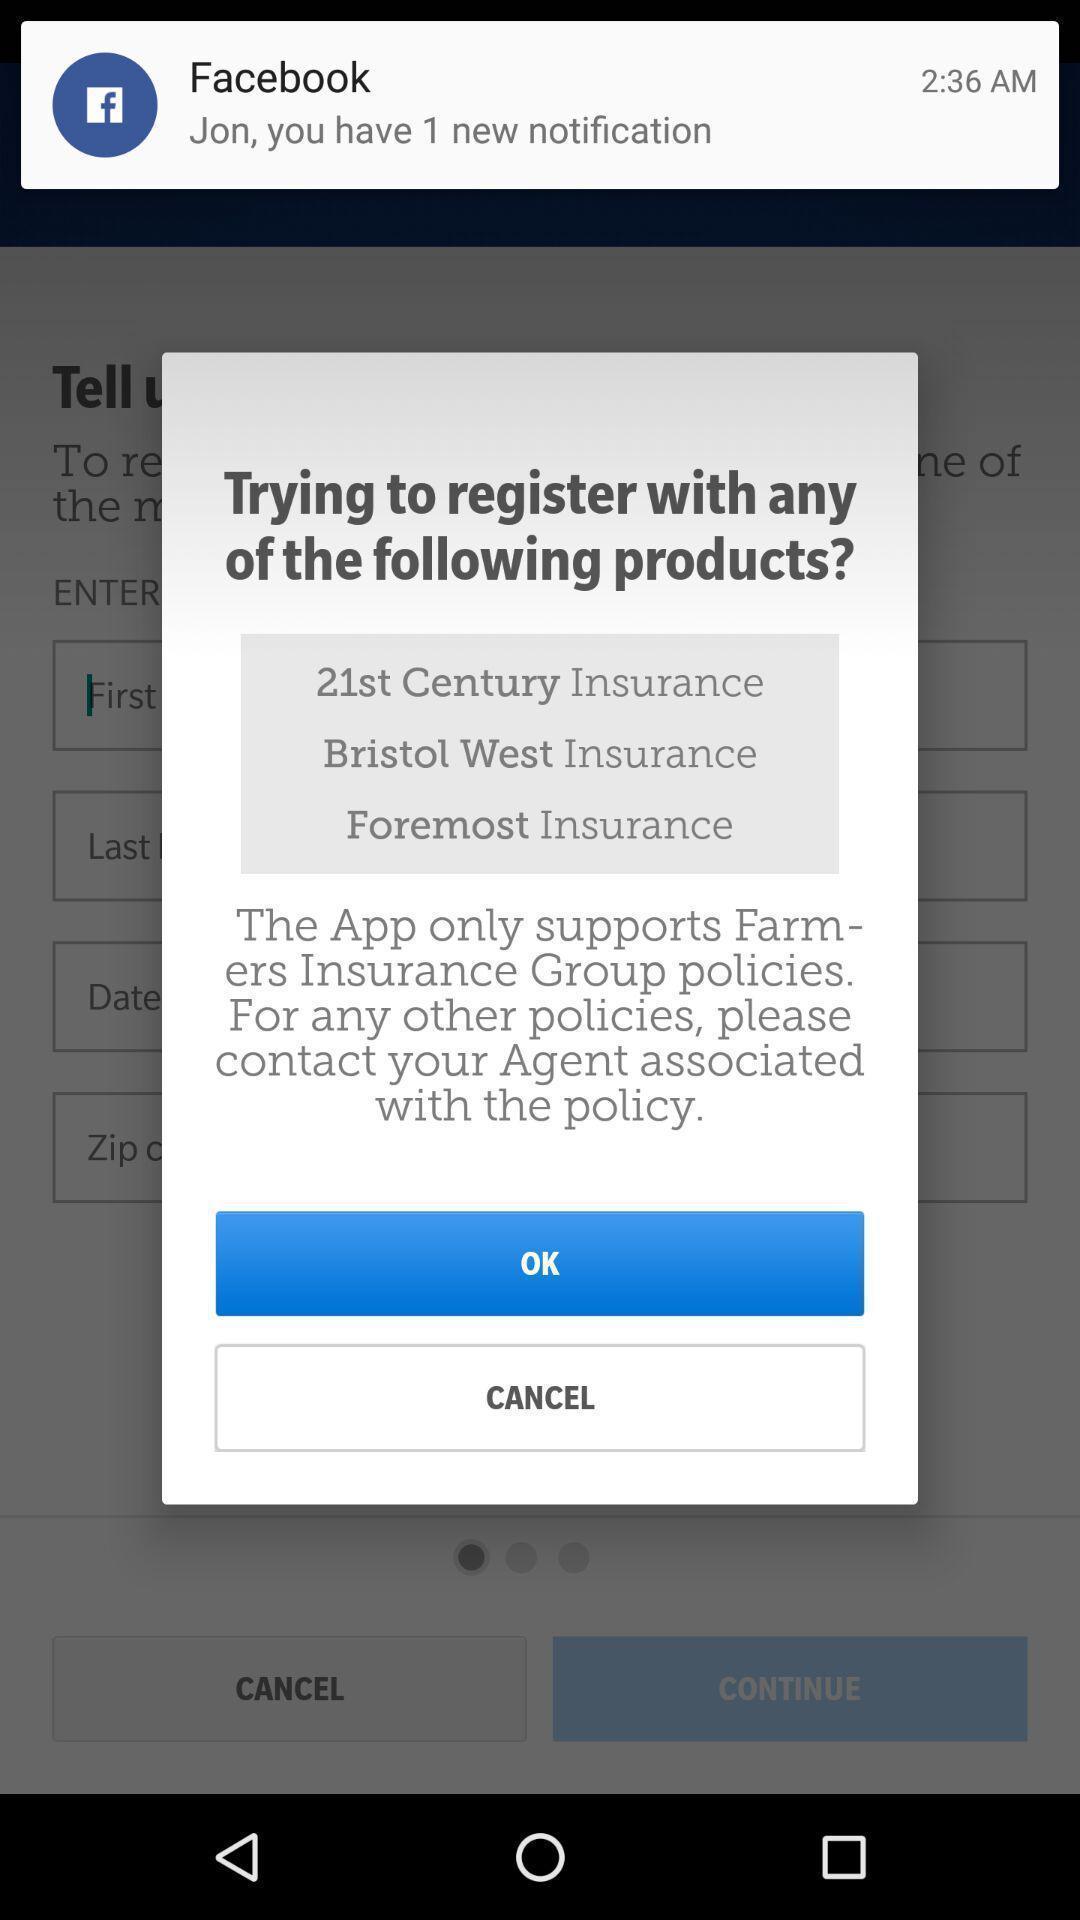Describe this image in words. Screen displaying the popup of a registration policy. 